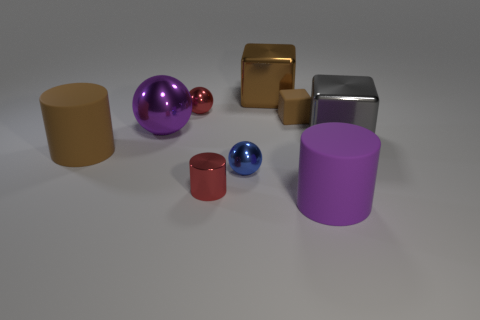Add 1 large green metal blocks. How many objects exist? 10 Subtract all spheres. How many objects are left? 6 Add 4 small cylinders. How many small cylinders exist? 5 Subtract 1 brown cylinders. How many objects are left? 8 Subtract all gray things. Subtract all red spheres. How many objects are left? 7 Add 7 purple metallic spheres. How many purple metallic spheres are left? 8 